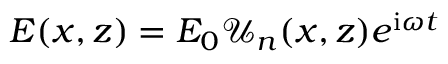<formula> <loc_0><loc_0><loc_500><loc_500>E ( x , z ) = E _ { 0 } \mathcal { U } _ { n } ( x , z ) e ^ { i \omega t }</formula> 